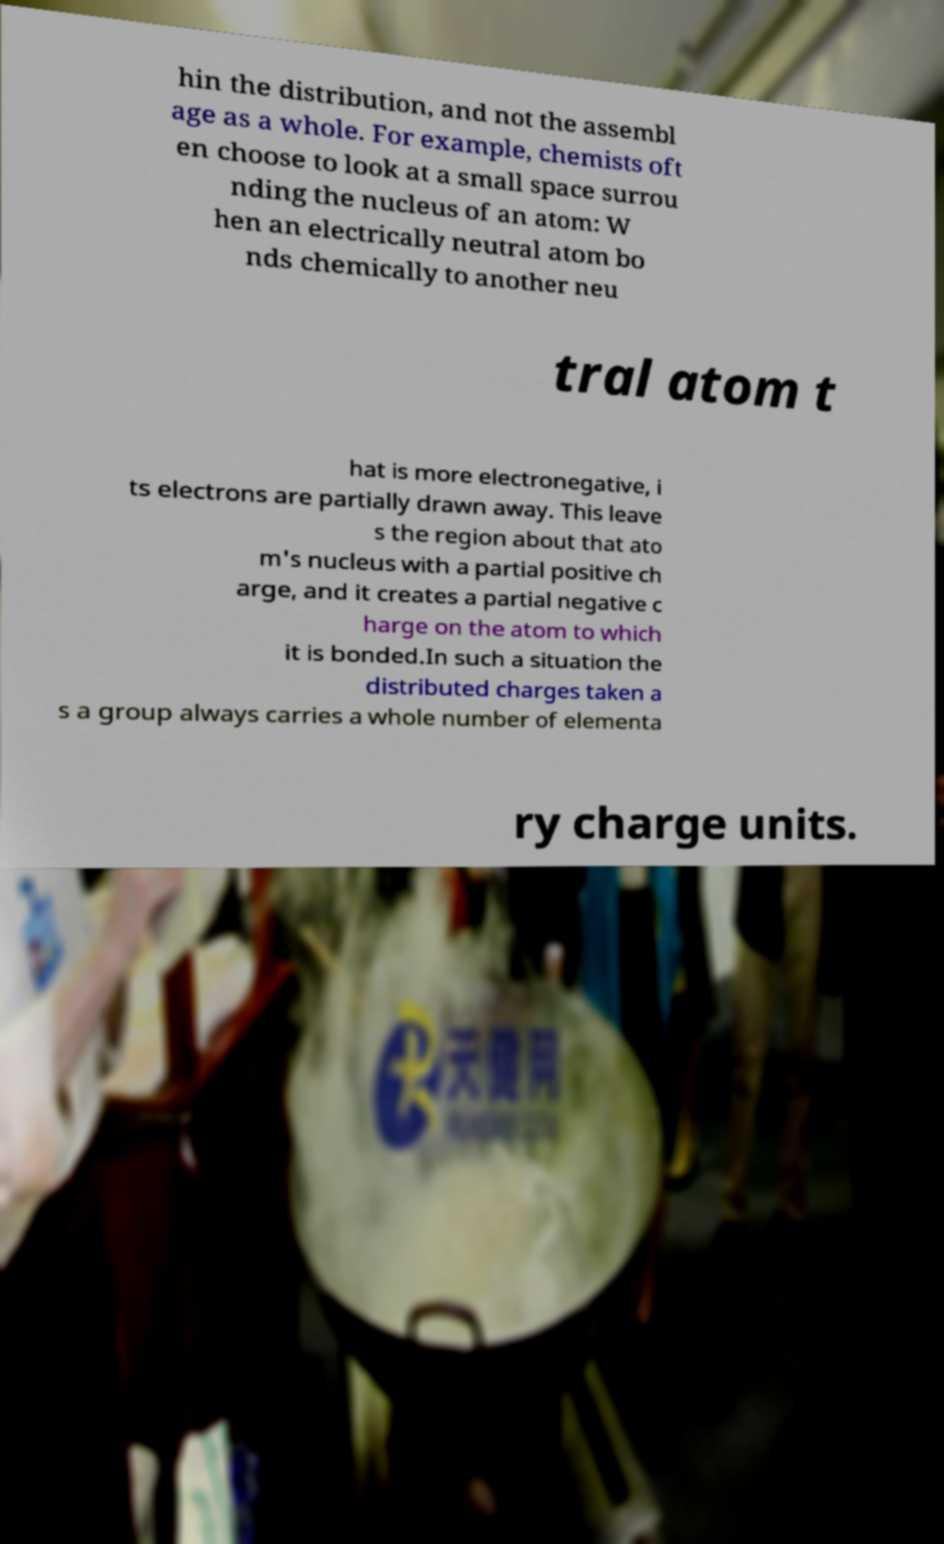Please identify and transcribe the text found in this image. hin the distribution, and not the assembl age as a whole. For example, chemists oft en choose to look at a small space surrou nding the nucleus of an atom: W hen an electrically neutral atom bo nds chemically to another neu tral atom t hat is more electronegative, i ts electrons are partially drawn away. This leave s the region about that ato m's nucleus with a partial positive ch arge, and it creates a partial negative c harge on the atom to which it is bonded.In such a situation the distributed charges taken a s a group always carries a whole number of elementa ry charge units. 